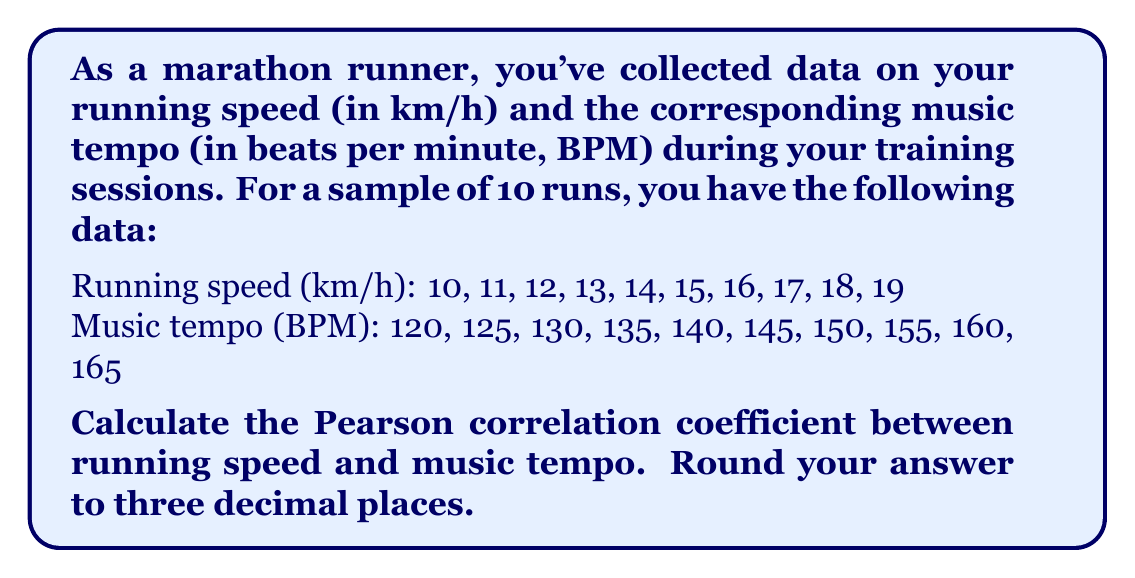Show me your answer to this math problem. To calculate the Pearson correlation coefficient, we'll follow these steps:

1. Calculate the means of running speed ($\bar{x}$) and music tempo ($\bar{y}$):

   $\bar{x} = \frac{10 + 11 + 12 + 13 + 14 + 15 + 16 + 17 + 18 + 19}{10} = 14.5$ km/h
   $\bar{y} = \frac{120 + 125 + 130 + 135 + 140 + 145 + 150 + 155 + 160 + 165}{10} = 142.5$ BPM

2. Calculate the deviations from the means:
   
   $x_i - \bar{x}$ and $y_i - \bar{y}$ for each data point

3. Calculate the products of the deviations:
   
   $(x_i - \bar{x})(y_i - \bar{y})$ for each data point

4. Sum the products of deviations:
   
   $\sum_{i=1}^{10} (x_i - \bar{x})(y_i - \bar{y}) = 225$

5. Calculate the sum of squared deviations for x and y:
   
   $\sum_{i=1}^{10} (x_i - \bar{x})^2 = 82.5$
   $\sum_{i=1}^{10} (y_i - \bar{y})^2 = 1375$

6. Apply the Pearson correlation coefficient formula:

   $$r = \frac{\sum_{i=1}^{n} (x_i - \bar{x})(y_i - \bar{y})}{\sqrt{\sum_{i=1}^{n} (x_i - \bar{x})^2 \sum_{i=1}^{n} (y_i - \bar{y})^2}}$$

   $$r = \frac{225}{\sqrt{82.5 \times 1375}} = \frac{225}{337.011} \approx 0.667$$

7. Round to three decimal places: 0.667
Answer: 0.667 